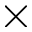Convert formula to latex. <formula><loc_0><loc_0><loc_500><loc_500>\times</formula> 